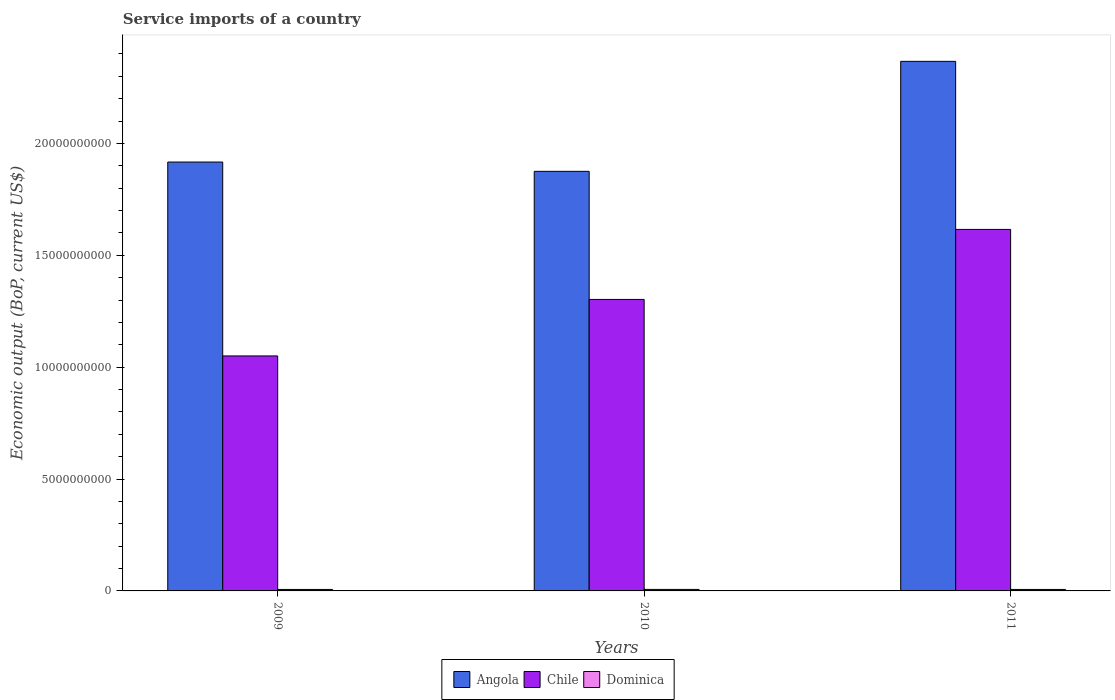How many different coloured bars are there?
Ensure brevity in your answer.  3. How many bars are there on the 2nd tick from the right?
Make the answer very short. 3. What is the service imports in Dominica in 2010?
Provide a succinct answer. 6.76e+07. Across all years, what is the maximum service imports in Dominica?
Provide a short and direct response. 6.76e+07. Across all years, what is the minimum service imports in Chile?
Your answer should be compact. 1.05e+1. In which year was the service imports in Dominica maximum?
Provide a short and direct response. 2010. What is the total service imports in Angola in the graph?
Make the answer very short. 6.16e+1. What is the difference between the service imports in Chile in 2009 and that in 2010?
Provide a short and direct response. -2.53e+09. What is the difference between the service imports in Chile in 2011 and the service imports in Dominica in 2009?
Provide a short and direct response. 1.61e+1. What is the average service imports in Angola per year?
Keep it short and to the point. 2.05e+1. In the year 2009, what is the difference between the service imports in Angola and service imports in Dominica?
Offer a terse response. 1.91e+1. What is the ratio of the service imports in Chile in 2009 to that in 2010?
Give a very brief answer. 0.81. Is the service imports in Angola in 2009 less than that in 2010?
Provide a succinct answer. No. What is the difference between the highest and the second highest service imports in Dominica?
Offer a very short reply. 1.36e+06. What is the difference between the highest and the lowest service imports in Dominica?
Provide a short and direct response. 1.73e+06. In how many years, is the service imports in Dominica greater than the average service imports in Dominica taken over all years?
Provide a succinct answer. 1. Is the sum of the service imports in Chile in 2009 and 2010 greater than the maximum service imports in Dominica across all years?
Your response must be concise. Yes. What does the 3rd bar from the right in 2009 represents?
Your answer should be compact. Angola. Is it the case that in every year, the sum of the service imports in Chile and service imports in Dominica is greater than the service imports in Angola?
Your answer should be compact. No. How many bars are there?
Your response must be concise. 9. Are all the bars in the graph horizontal?
Make the answer very short. No. Does the graph contain any zero values?
Offer a very short reply. No. Does the graph contain grids?
Offer a terse response. No. How are the legend labels stacked?
Offer a very short reply. Horizontal. What is the title of the graph?
Your response must be concise. Service imports of a country. Does "Australia" appear as one of the legend labels in the graph?
Your answer should be very brief. No. What is the label or title of the Y-axis?
Your answer should be compact. Economic output (BoP, current US$). What is the Economic output (BoP, current US$) in Angola in 2009?
Keep it short and to the point. 1.92e+1. What is the Economic output (BoP, current US$) of Chile in 2009?
Offer a very short reply. 1.05e+1. What is the Economic output (BoP, current US$) in Dominica in 2009?
Offer a very short reply. 6.62e+07. What is the Economic output (BoP, current US$) in Angola in 2010?
Your answer should be very brief. 1.88e+1. What is the Economic output (BoP, current US$) of Chile in 2010?
Make the answer very short. 1.30e+1. What is the Economic output (BoP, current US$) of Dominica in 2010?
Your response must be concise. 6.76e+07. What is the Economic output (BoP, current US$) in Angola in 2011?
Provide a short and direct response. 2.37e+1. What is the Economic output (BoP, current US$) in Chile in 2011?
Give a very brief answer. 1.62e+1. What is the Economic output (BoP, current US$) of Dominica in 2011?
Provide a succinct answer. 6.59e+07. Across all years, what is the maximum Economic output (BoP, current US$) of Angola?
Make the answer very short. 2.37e+1. Across all years, what is the maximum Economic output (BoP, current US$) of Chile?
Offer a very short reply. 1.62e+1. Across all years, what is the maximum Economic output (BoP, current US$) of Dominica?
Make the answer very short. 6.76e+07. Across all years, what is the minimum Economic output (BoP, current US$) in Angola?
Offer a very short reply. 1.88e+1. Across all years, what is the minimum Economic output (BoP, current US$) in Chile?
Your answer should be very brief. 1.05e+1. Across all years, what is the minimum Economic output (BoP, current US$) in Dominica?
Provide a succinct answer. 6.59e+07. What is the total Economic output (BoP, current US$) of Angola in the graph?
Your answer should be compact. 6.16e+1. What is the total Economic output (BoP, current US$) in Chile in the graph?
Give a very brief answer. 3.97e+1. What is the total Economic output (BoP, current US$) in Dominica in the graph?
Your answer should be compact. 2.00e+08. What is the difference between the Economic output (BoP, current US$) in Angola in 2009 and that in 2010?
Give a very brief answer. 4.15e+08. What is the difference between the Economic output (BoP, current US$) in Chile in 2009 and that in 2010?
Your answer should be very brief. -2.53e+09. What is the difference between the Economic output (BoP, current US$) in Dominica in 2009 and that in 2010?
Provide a short and direct response. -1.36e+06. What is the difference between the Economic output (BoP, current US$) in Angola in 2009 and that in 2011?
Keep it short and to the point. -4.50e+09. What is the difference between the Economic output (BoP, current US$) of Chile in 2009 and that in 2011?
Offer a very short reply. -5.66e+09. What is the difference between the Economic output (BoP, current US$) of Dominica in 2009 and that in 2011?
Your answer should be very brief. 3.70e+05. What is the difference between the Economic output (BoP, current US$) in Angola in 2010 and that in 2011?
Keep it short and to the point. -4.92e+09. What is the difference between the Economic output (BoP, current US$) of Chile in 2010 and that in 2011?
Keep it short and to the point. -3.13e+09. What is the difference between the Economic output (BoP, current US$) of Dominica in 2010 and that in 2011?
Offer a very short reply. 1.73e+06. What is the difference between the Economic output (BoP, current US$) of Angola in 2009 and the Economic output (BoP, current US$) of Chile in 2010?
Provide a short and direct response. 6.14e+09. What is the difference between the Economic output (BoP, current US$) of Angola in 2009 and the Economic output (BoP, current US$) of Dominica in 2010?
Offer a terse response. 1.91e+1. What is the difference between the Economic output (BoP, current US$) of Chile in 2009 and the Economic output (BoP, current US$) of Dominica in 2010?
Make the answer very short. 1.04e+1. What is the difference between the Economic output (BoP, current US$) of Angola in 2009 and the Economic output (BoP, current US$) of Chile in 2011?
Provide a short and direct response. 3.01e+09. What is the difference between the Economic output (BoP, current US$) in Angola in 2009 and the Economic output (BoP, current US$) in Dominica in 2011?
Ensure brevity in your answer.  1.91e+1. What is the difference between the Economic output (BoP, current US$) in Chile in 2009 and the Economic output (BoP, current US$) in Dominica in 2011?
Ensure brevity in your answer.  1.04e+1. What is the difference between the Economic output (BoP, current US$) of Angola in 2010 and the Economic output (BoP, current US$) of Chile in 2011?
Make the answer very short. 2.60e+09. What is the difference between the Economic output (BoP, current US$) in Angola in 2010 and the Economic output (BoP, current US$) in Dominica in 2011?
Your answer should be compact. 1.87e+1. What is the difference between the Economic output (BoP, current US$) in Chile in 2010 and the Economic output (BoP, current US$) in Dominica in 2011?
Offer a very short reply. 1.30e+1. What is the average Economic output (BoP, current US$) of Angola per year?
Offer a terse response. 2.05e+1. What is the average Economic output (BoP, current US$) in Chile per year?
Offer a very short reply. 1.32e+1. What is the average Economic output (BoP, current US$) in Dominica per year?
Your answer should be very brief. 6.66e+07. In the year 2009, what is the difference between the Economic output (BoP, current US$) of Angola and Economic output (BoP, current US$) of Chile?
Make the answer very short. 8.67e+09. In the year 2009, what is the difference between the Economic output (BoP, current US$) in Angola and Economic output (BoP, current US$) in Dominica?
Keep it short and to the point. 1.91e+1. In the year 2009, what is the difference between the Economic output (BoP, current US$) of Chile and Economic output (BoP, current US$) of Dominica?
Make the answer very short. 1.04e+1. In the year 2010, what is the difference between the Economic output (BoP, current US$) of Angola and Economic output (BoP, current US$) of Chile?
Give a very brief answer. 5.73e+09. In the year 2010, what is the difference between the Economic output (BoP, current US$) of Angola and Economic output (BoP, current US$) of Dominica?
Keep it short and to the point. 1.87e+1. In the year 2010, what is the difference between the Economic output (BoP, current US$) in Chile and Economic output (BoP, current US$) in Dominica?
Keep it short and to the point. 1.30e+1. In the year 2011, what is the difference between the Economic output (BoP, current US$) in Angola and Economic output (BoP, current US$) in Chile?
Offer a very short reply. 7.51e+09. In the year 2011, what is the difference between the Economic output (BoP, current US$) of Angola and Economic output (BoP, current US$) of Dominica?
Keep it short and to the point. 2.36e+1. In the year 2011, what is the difference between the Economic output (BoP, current US$) in Chile and Economic output (BoP, current US$) in Dominica?
Your answer should be compact. 1.61e+1. What is the ratio of the Economic output (BoP, current US$) of Angola in 2009 to that in 2010?
Your answer should be compact. 1.02. What is the ratio of the Economic output (BoP, current US$) of Chile in 2009 to that in 2010?
Provide a short and direct response. 0.81. What is the ratio of the Economic output (BoP, current US$) in Dominica in 2009 to that in 2010?
Provide a short and direct response. 0.98. What is the ratio of the Economic output (BoP, current US$) in Angola in 2009 to that in 2011?
Offer a terse response. 0.81. What is the ratio of the Economic output (BoP, current US$) in Chile in 2009 to that in 2011?
Your answer should be compact. 0.65. What is the ratio of the Economic output (BoP, current US$) in Dominica in 2009 to that in 2011?
Offer a terse response. 1.01. What is the ratio of the Economic output (BoP, current US$) of Angola in 2010 to that in 2011?
Ensure brevity in your answer.  0.79. What is the ratio of the Economic output (BoP, current US$) of Chile in 2010 to that in 2011?
Offer a very short reply. 0.81. What is the ratio of the Economic output (BoP, current US$) of Dominica in 2010 to that in 2011?
Give a very brief answer. 1.03. What is the difference between the highest and the second highest Economic output (BoP, current US$) of Angola?
Make the answer very short. 4.50e+09. What is the difference between the highest and the second highest Economic output (BoP, current US$) of Chile?
Provide a succinct answer. 3.13e+09. What is the difference between the highest and the second highest Economic output (BoP, current US$) in Dominica?
Keep it short and to the point. 1.36e+06. What is the difference between the highest and the lowest Economic output (BoP, current US$) of Angola?
Your answer should be compact. 4.92e+09. What is the difference between the highest and the lowest Economic output (BoP, current US$) in Chile?
Keep it short and to the point. 5.66e+09. What is the difference between the highest and the lowest Economic output (BoP, current US$) of Dominica?
Provide a succinct answer. 1.73e+06. 